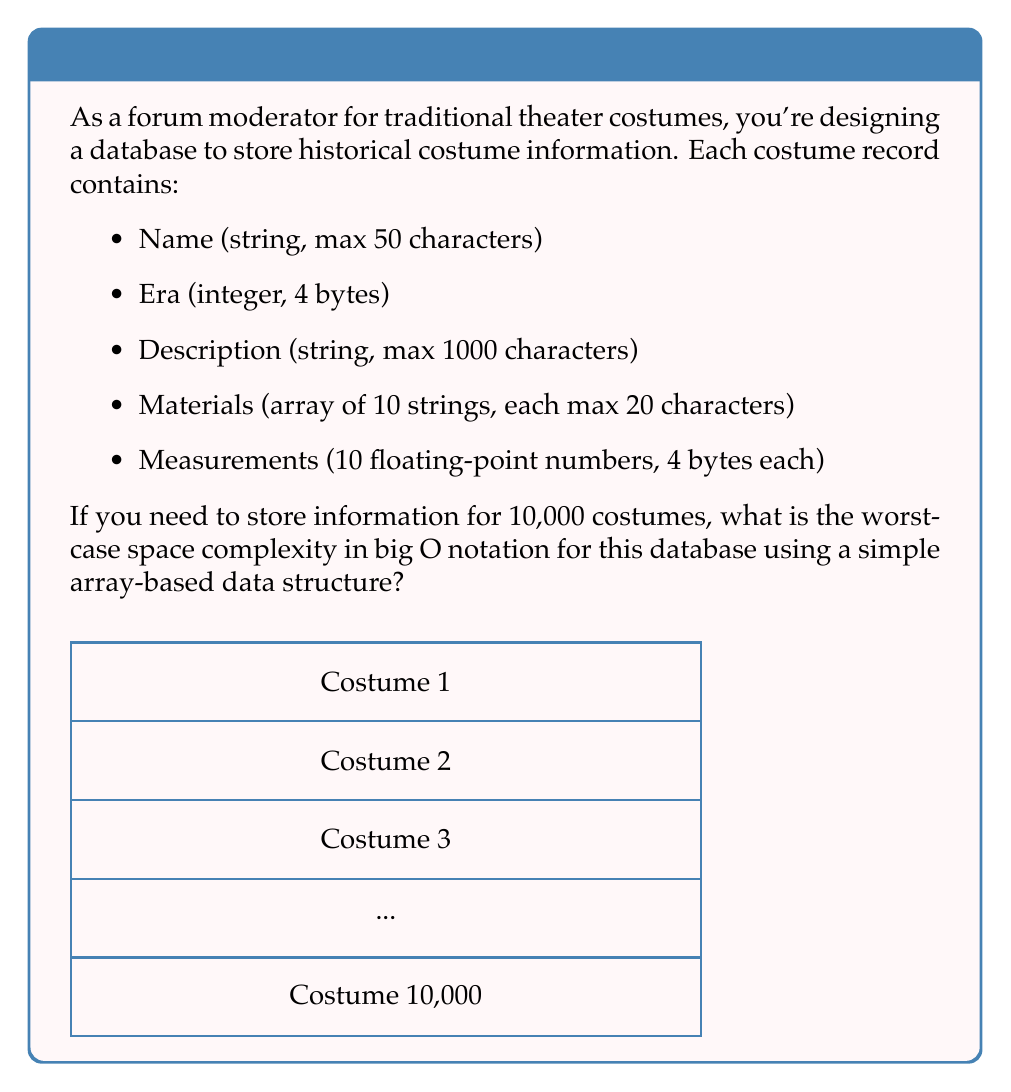Teach me how to tackle this problem. Let's break down the space required for each costume record:

1. Name: 50 characters * 1 byte/character = 50 bytes
2. Era: 4 bytes
3. Description: 1000 characters * 1 byte/character = 1000 bytes
4. Materials: 10 * 20 characters * 1 byte/character = 200 bytes
5. Measurements: 10 * 4 bytes = 40 bytes

Total space per costume = 50 + 4 + 1000 + 200 + 40 = 1294 bytes

For 10,000 costumes, the total space required would be:
10,000 * 1294 bytes = 12,940,000 bytes

In big O notation, we express this as $O(n)$, where $n$ is the number of costumes. This is because the space required grows linearly with the number of costume records.

The constant factors and lower-order terms are dropped in big O notation, so even though we have a large constant (1294), it doesn't affect the overall complexity.

It's worth noting that this is a worst-case scenario, assuming all strings use their maximum allocated space. In practice, many strings might be shorter, but big O notation considers the worst case.

Also, the use of a simple array-based structure means that we don't have any additional overhead for more complex data structures like linked lists or trees, which could potentially add logarithmic or constant factors to the space complexity.
Answer: $O(n)$ 